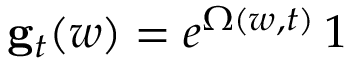Convert formula to latex. <formula><loc_0><loc_0><loc_500><loc_500>{ g } _ { t } ( w ) = e ^ { \Omega ( w , t ) } \, 1</formula> 